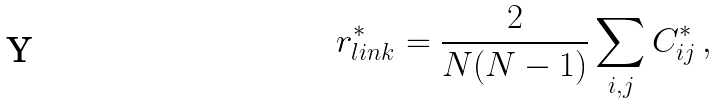<formula> <loc_0><loc_0><loc_500><loc_500>r ^ { * } _ { l i n k } = \frac { 2 } { N ( N - 1 ) } \sum _ { i , j } C ^ { * } _ { i j } \, ,</formula> 